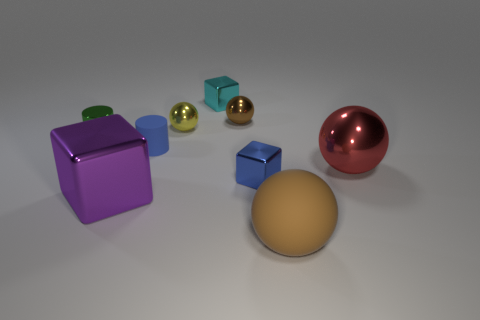Is the number of brown metallic things that are in front of the big metallic block the same as the number of small brown spheres?
Your answer should be very brief. No. What size is the metal cylinder?
Give a very brief answer. Small. What is the material of the object that is the same color as the small rubber cylinder?
Provide a succinct answer. Metal. How many shiny objects have the same color as the large matte ball?
Offer a very short reply. 1. Does the blue rubber cylinder have the same size as the brown shiny thing?
Keep it short and to the point. Yes. There is a blue object that is in front of the cylinder on the right side of the purple block; how big is it?
Your answer should be compact. Small. There is a large shiny block; is its color the same as the small metal block behind the red metal ball?
Offer a terse response. No. Are there any red things of the same size as the brown matte ball?
Your response must be concise. Yes. There is a red object to the right of the big brown matte object; how big is it?
Provide a short and direct response. Large. Is there a tiny blue thing behind the metallic block that is in front of the small blue shiny block?
Your answer should be compact. Yes. 